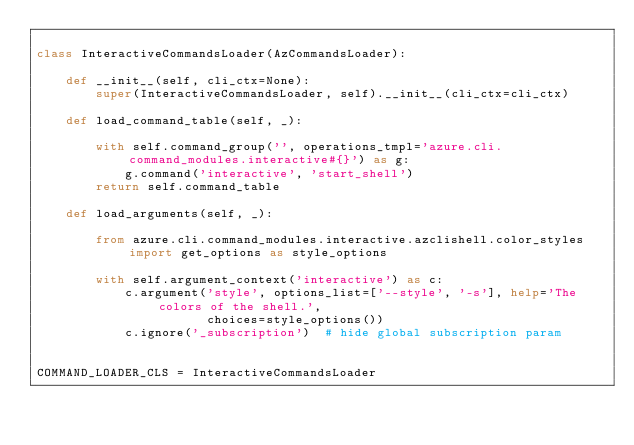<code> <loc_0><loc_0><loc_500><loc_500><_Python_>
class InteractiveCommandsLoader(AzCommandsLoader):

    def __init__(self, cli_ctx=None):
        super(InteractiveCommandsLoader, self).__init__(cli_ctx=cli_ctx)

    def load_command_table(self, _):

        with self.command_group('', operations_tmpl='azure.cli.command_modules.interactive#{}') as g:
            g.command('interactive', 'start_shell')
        return self.command_table

    def load_arguments(self, _):

        from azure.cli.command_modules.interactive.azclishell.color_styles import get_options as style_options

        with self.argument_context('interactive') as c:
            c.argument('style', options_list=['--style', '-s'], help='The colors of the shell.',
                       choices=style_options())
            c.ignore('_subscription')  # hide global subscription param


COMMAND_LOADER_CLS = InteractiveCommandsLoader
</code> 